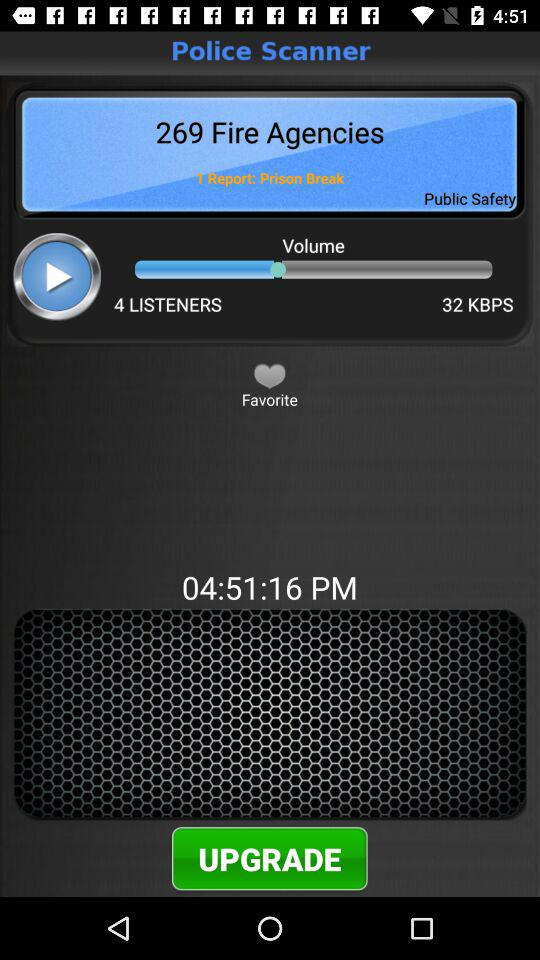What is the time? The time is 04:51:16 PM. 